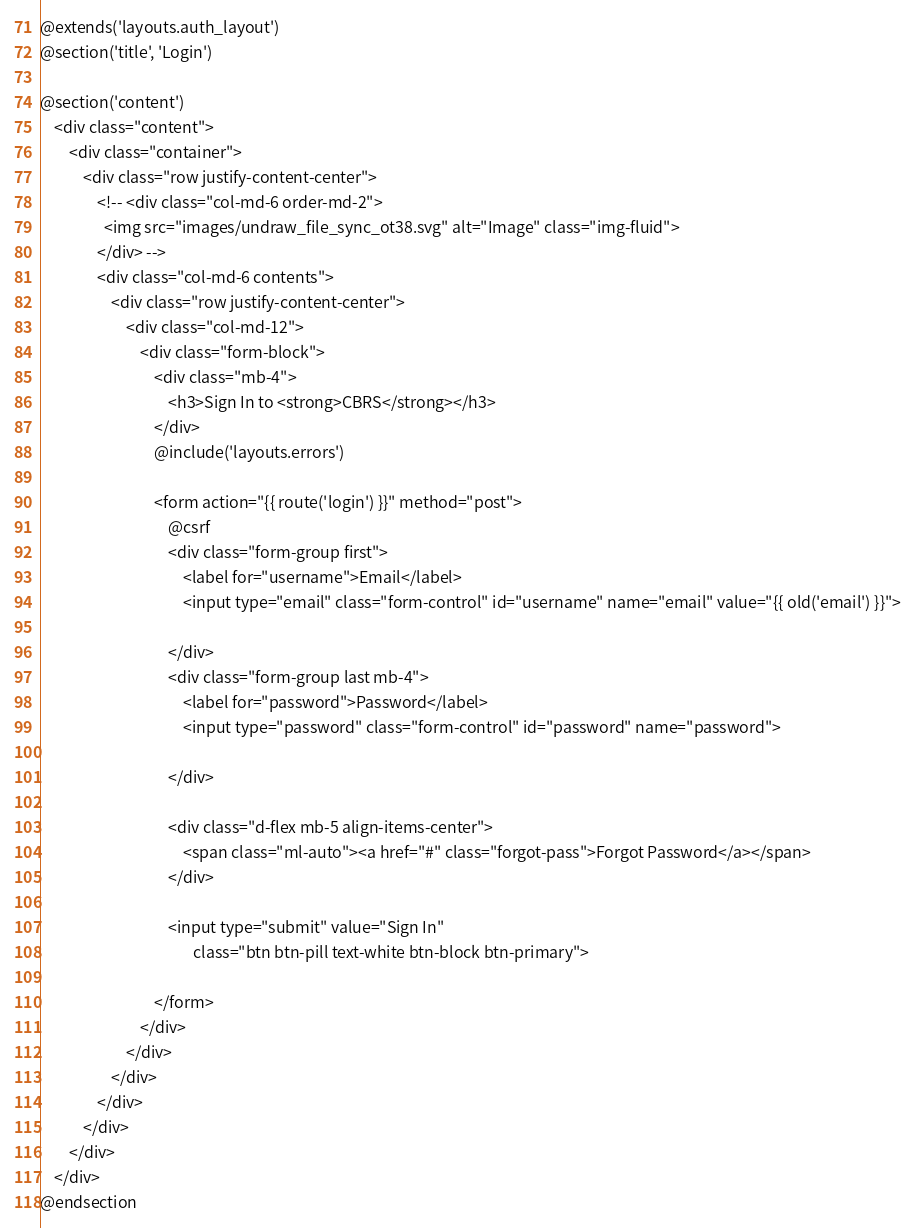Convert code to text. <code><loc_0><loc_0><loc_500><loc_500><_PHP_>@extends('layouts.auth_layout')
@section('title', 'Login')

@section('content')
    <div class="content">
        <div class="container">
            <div class="row justify-content-center">
                <!-- <div class="col-md-6 order-md-2">
                  <img src="images/undraw_file_sync_ot38.svg" alt="Image" class="img-fluid">
                </div> -->
                <div class="col-md-6 contents">
                    <div class="row justify-content-center">
                        <div class="col-md-12">
                            <div class="form-block">
                                <div class="mb-4">
                                    <h3>Sign In to <strong>CBRS</strong></h3>
                                </div>
                                @include('layouts.errors')

                                <form action="{{ route('login') }}" method="post">
                                    @csrf
                                    <div class="form-group first">
                                        <label for="username">Email</label>
                                        <input type="email" class="form-control" id="username" name="email" value="{{ old('email') }}">

                                    </div>
                                    <div class="form-group last mb-4">
                                        <label for="password">Password</label>
                                        <input type="password" class="form-control" id="password" name="password">

                                    </div>

                                    <div class="d-flex mb-5 align-items-center">
                                        <span class="ml-auto"><a href="#" class="forgot-pass">Forgot Password</a></span>
                                    </div>

                                    <input type="submit" value="Sign In"
                                           class="btn btn-pill text-white btn-block btn-primary">

                                </form>
                            </div>
                        </div>
                    </div>
                </div>
            </div>
        </div>
    </div>
@endsection
</code> 